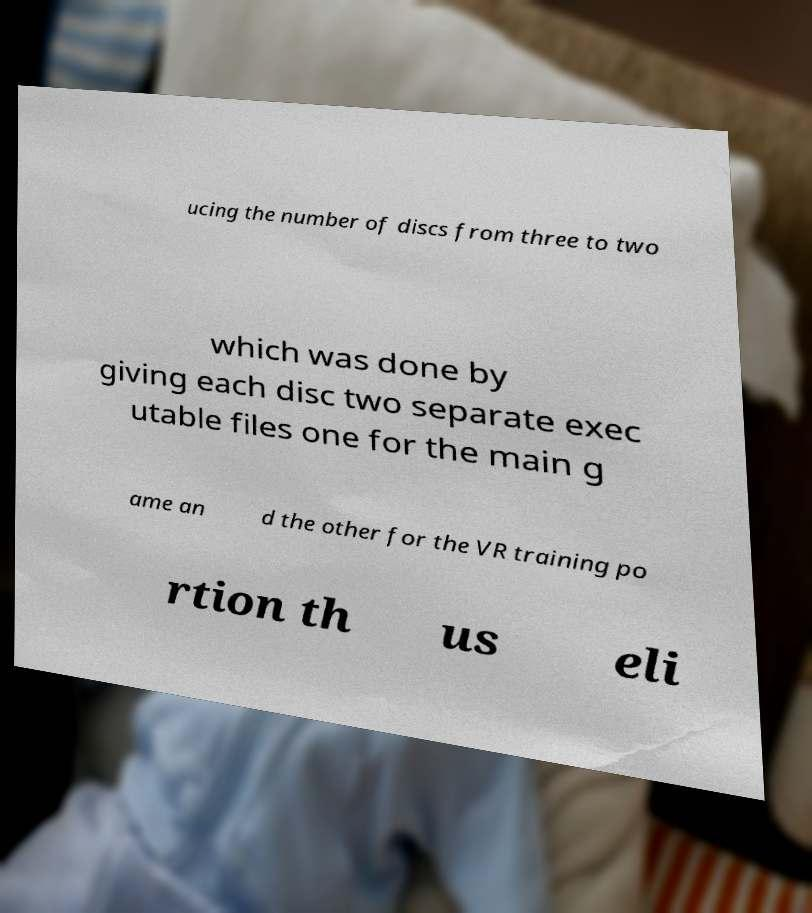I need the written content from this picture converted into text. Can you do that? ucing the number of discs from three to two which was done by giving each disc two separate exec utable files one for the main g ame an d the other for the VR training po rtion th us eli 